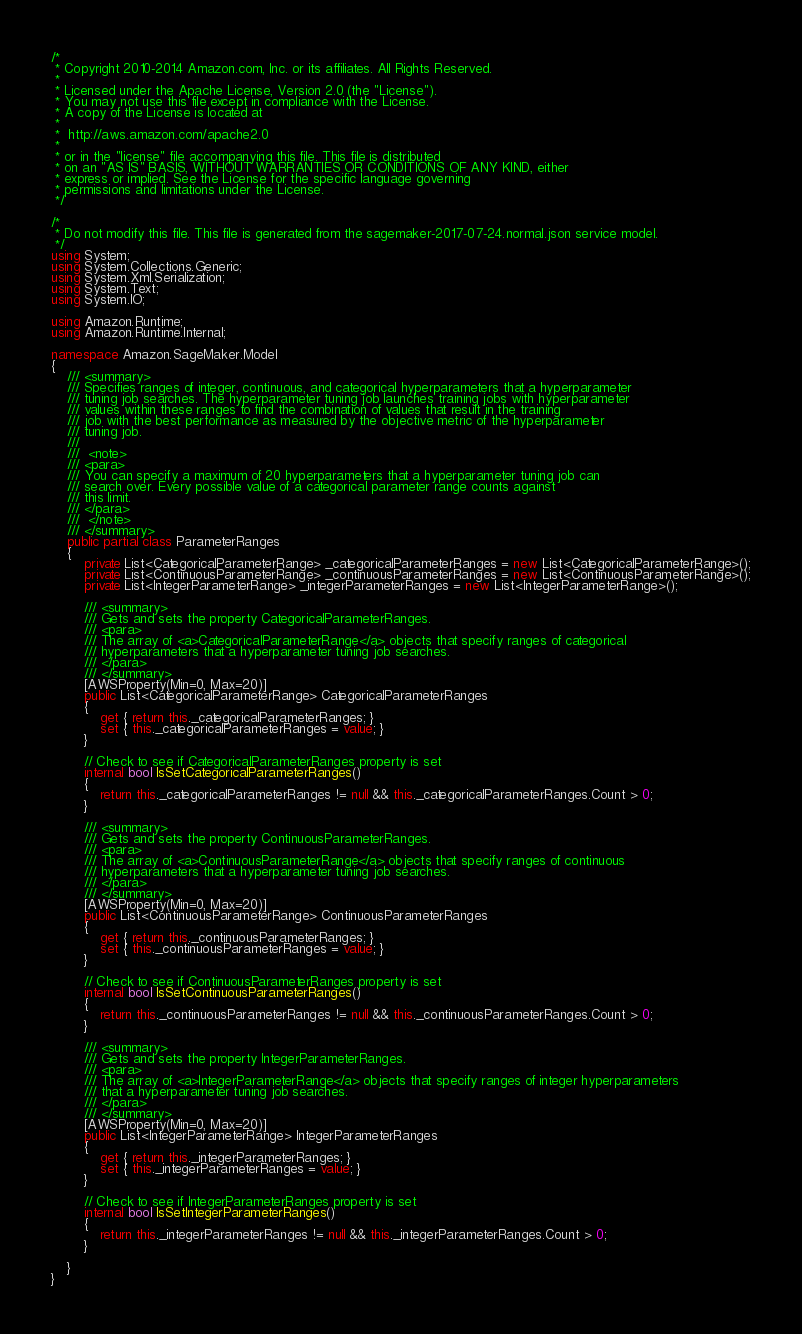Convert code to text. <code><loc_0><loc_0><loc_500><loc_500><_C#_>/*
 * Copyright 2010-2014 Amazon.com, Inc. or its affiliates. All Rights Reserved.
 * 
 * Licensed under the Apache License, Version 2.0 (the "License").
 * You may not use this file except in compliance with the License.
 * A copy of the License is located at
 * 
 *  http://aws.amazon.com/apache2.0
 * 
 * or in the "license" file accompanying this file. This file is distributed
 * on an "AS IS" BASIS, WITHOUT WARRANTIES OR CONDITIONS OF ANY KIND, either
 * express or implied. See the License for the specific language governing
 * permissions and limitations under the License.
 */

/*
 * Do not modify this file. This file is generated from the sagemaker-2017-07-24.normal.json service model.
 */
using System;
using System.Collections.Generic;
using System.Xml.Serialization;
using System.Text;
using System.IO;

using Amazon.Runtime;
using Amazon.Runtime.Internal;

namespace Amazon.SageMaker.Model
{
    /// <summary>
    /// Specifies ranges of integer, continuous, and categorical hyperparameters that a hyperparameter
    /// tuning job searches. The hyperparameter tuning job launches training jobs with hyperparameter
    /// values within these ranges to find the combination of values that result in the training
    /// job with the best performance as measured by the objective metric of the hyperparameter
    /// tuning job.
    /// 
    ///  <note> 
    /// <para>
    /// You can specify a maximum of 20 hyperparameters that a hyperparameter tuning job can
    /// search over. Every possible value of a categorical parameter range counts against
    /// this limit.
    /// </para>
    ///  </note>
    /// </summary>
    public partial class ParameterRanges
    {
        private List<CategoricalParameterRange> _categoricalParameterRanges = new List<CategoricalParameterRange>();
        private List<ContinuousParameterRange> _continuousParameterRanges = new List<ContinuousParameterRange>();
        private List<IntegerParameterRange> _integerParameterRanges = new List<IntegerParameterRange>();

        /// <summary>
        /// Gets and sets the property CategoricalParameterRanges. 
        /// <para>
        /// The array of <a>CategoricalParameterRange</a> objects that specify ranges of categorical
        /// hyperparameters that a hyperparameter tuning job searches.
        /// </para>
        /// </summary>
        [AWSProperty(Min=0, Max=20)]
        public List<CategoricalParameterRange> CategoricalParameterRanges
        {
            get { return this._categoricalParameterRanges; }
            set { this._categoricalParameterRanges = value; }
        }

        // Check to see if CategoricalParameterRanges property is set
        internal bool IsSetCategoricalParameterRanges()
        {
            return this._categoricalParameterRanges != null && this._categoricalParameterRanges.Count > 0; 
        }

        /// <summary>
        /// Gets and sets the property ContinuousParameterRanges. 
        /// <para>
        /// The array of <a>ContinuousParameterRange</a> objects that specify ranges of continuous
        /// hyperparameters that a hyperparameter tuning job searches.
        /// </para>
        /// </summary>
        [AWSProperty(Min=0, Max=20)]
        public List<ContinuousParameterRange> ContinuousParameterRanges
        {
            get { return this._continuousParameterRanges; }
            set { this._continuousParameterRanges = value; }
        }

        // Check to see if ContinuousParameterRanges property is set
        internal bool IsSetContinuousParameterRanges()
        {
            return this._continuousParameterRanges != null && this._continuousParameterRanges.Count > 0; 
        }

        /// <summary>
        /// Gets and sets the property IntegerParameterRanges. 
        /// <para>
        /// The array of <a>IntegerParameterRange</a> objects that specify ranges of integer hyperparameters
        /// that a hyperparameter tuning job searches.
        /// </para>
        /// </summary>
        [AWSProperty(Min=0, Max=20)]
        public List<IntegerParameterRange> IntegerParameterRanges
        {
            get { return this._integerParameterRanges; }
            set { this._integerParameterRanges = value; }
        }

        // Check to see if IntegerParameterRanges property is set
        internal bool IsSetIntegerParameterRanges()
        {
            return this._integerParameterRanges != null && this._integerParameterRanges.Count > 0; 
        }

    }
}</code> 